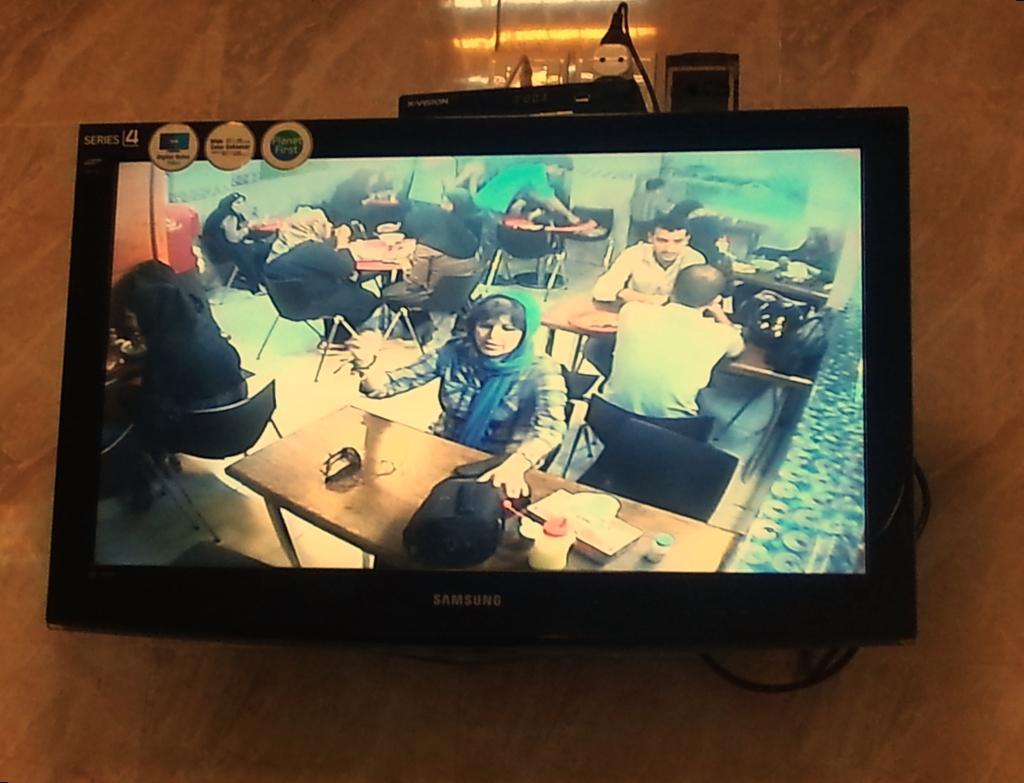What type of display is featured in the image? The image contains a LED-backlit LCD display. Can you describe the technology used in the display? The display uses LED-backlit technology for illumination, and it is an LCD display for image rendering. What type of harmony is being played on the appliance in the image? There is no appliance or music present in the image; it only features a LED-backlit LCD display. 